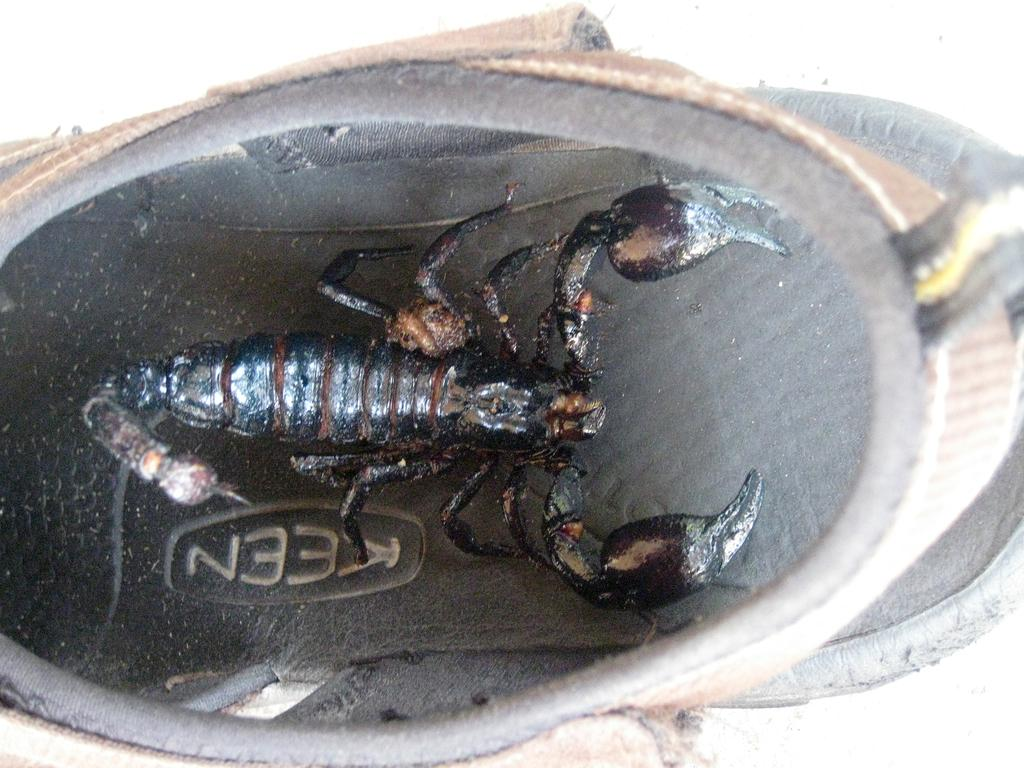<image>
Summarize the visual content of the image. A black scorpion logo that is made by Keen 